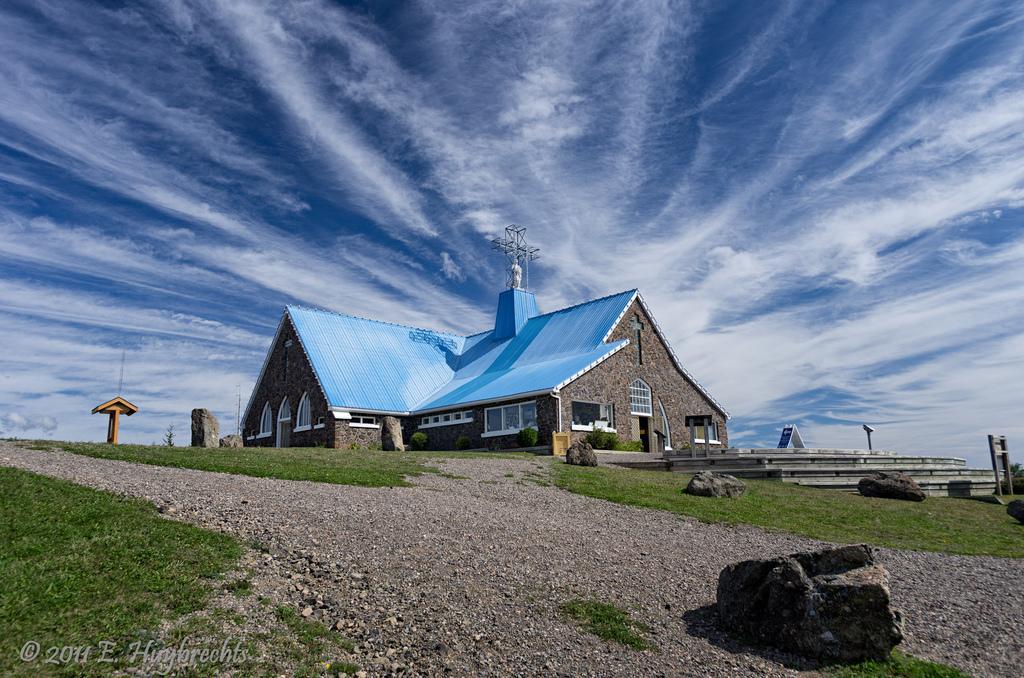Can you describe this image briefly? In this image I can see a building which is brown and black in color and the roof of it is blue in color. On the top of it I can see few metal rods and I can see few windows of the building. I can see the road, some grass, few wooden logs and a yellow colored object. In the background I can see the sky. 